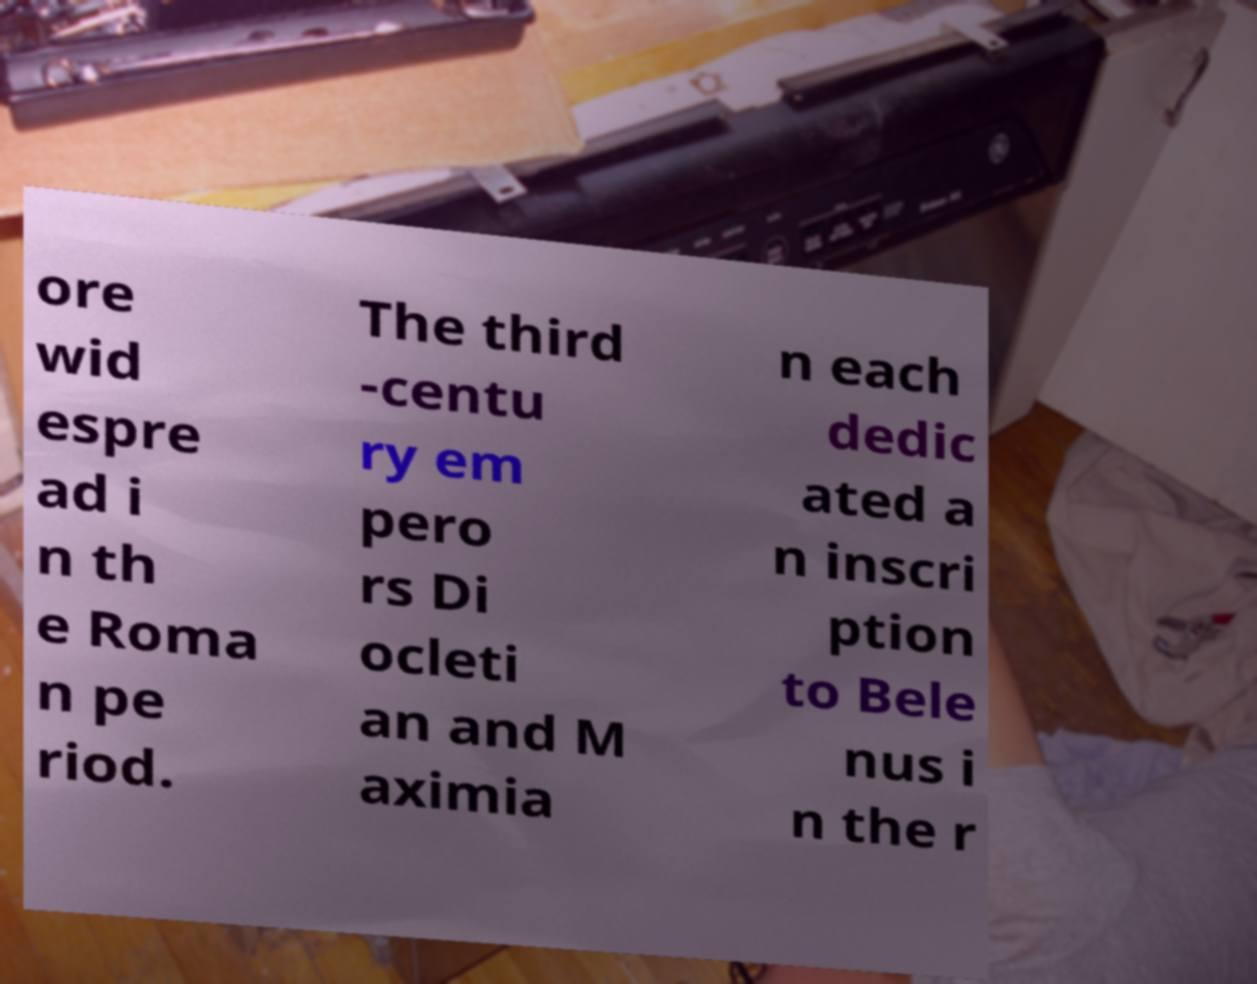Please identify and transcribe the text found in this image. ore wid espre ad i n th e Roma n pe riod. The third -centu ry em pero rs Di ocleti an and M aximia n each dedic ated a n inscri ption to Bele nus i n the r 